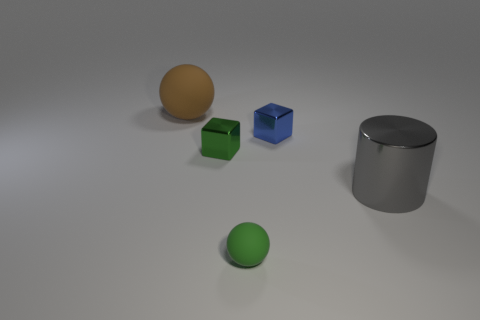What is the material of the blue cube?
Your response must be concise. Metal. What is the shape of the green object that is to the left of the green thing in front of the metallic cube left of the blue metallic cube?
Your response must be concise. Cube. Is the number of large brown spheres in front of the tiny green cube greater than the number of shiny cylinders?
Provide a short and direct response. No. Do the large brown rubber object and the matte object that is in front of the large rubber object have the same shape?
Your answer should be compact. Yes. There is a metallic object that is the same color as the tiny matte ball; what shape is it?
Offer a very short reply. Cube. How many tiny matte objects are in front of the tiny metallic thing to the left of the object in front of the metal cylinder?
Your answer should be very brief. 1. The sphere that is the same size as the gray shiny object is what color?
Your answer should be compact. Brown. What size is the green thing that is in front of the small shiny object on the left side of the green matte ball?
Provide a succinct answer. Small. What is the size of the thing that is the same color as the tiny matte sphere?
Ensure brevity in your answer.  Small. How many other objects are there of the same size as the metal cylinder?
Offer a terse response. 1. 